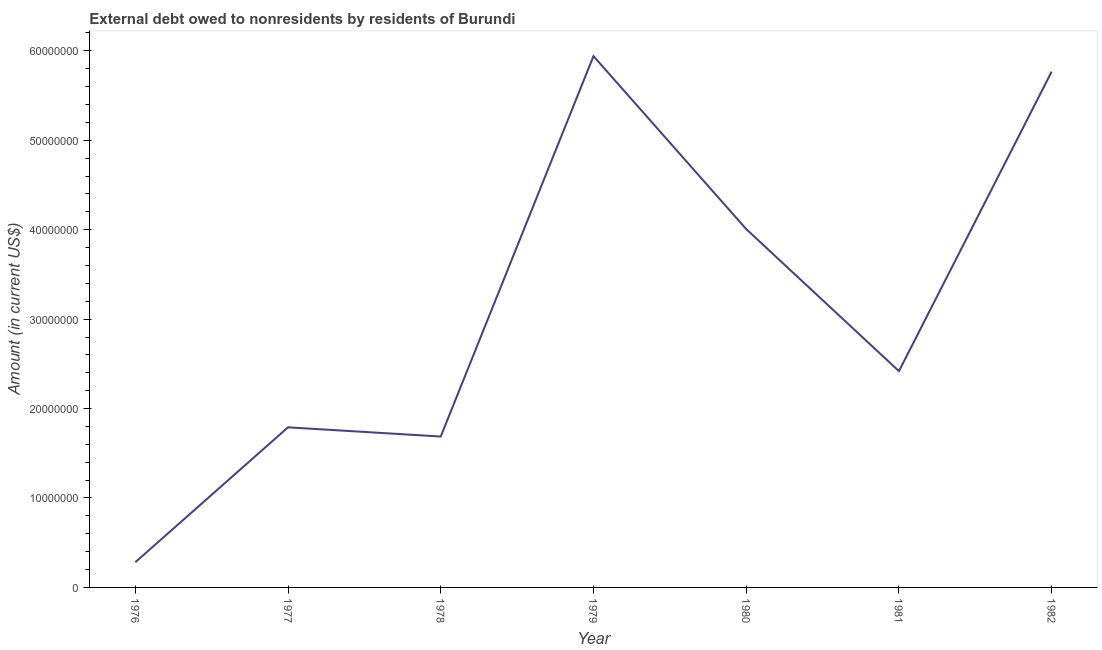What is the debt in 1979?
Provide a succinct answer. 5.94e+07. Across all years, what is the maximum debt?
Make the answer very short. 5.94e+07. Across all years, what is the minimum debt?
Offer a terse response. 2.81e+06. In which year was the debt maximum?
Provide a succinct answer. 1979. In which year was the debt minimum?
Provide a short and direct response. 1976. What is the sum of the debt?
Provide a short and direct response. 2.19e+08. What is the difference between the debt in 1976 and 1981?
Provide a succinct answer. -2.14e+07. What is the average debt per year?
Keep it short and to the point. 3.13e+07. What is the median debt?
Provide a succinct answer. 2.42e+07. What is the ratio of the debt in 1976 to that in 1982?
Offer a terse response. 0.05. Is the difference between the debt in 1976 and 1981 greater than the difference between any two years?
Provide a succinct answer. No. What is the difference between the highest and the second highest debt?
Provide a succinct answer. 1.73e+06. What is the difference between the highest and the lowest debt?
Your answer should be very brief. 5.66e+07. In how many years, is the debt greater than the average debt taken over all years?
Make the answer very short. 3. How many lines are there?
Provide a succinct answer. 1. How many years are there in the graph?
Keep it short and to the point. 7. What is the title of the graph?
Your answer should be compact. External debt owed to nonresidents by residents of Burundi. What is the label or title of the X-axis?
Give a very brief answer. Year. What is the label or title of the Y-axis?
Offer a very short reply. Amount (in current US$). What is the Amount (in current US$) in 1976?
Give a very brief answer. 2.81e+06. What is the Amount (in current US$) of 1977?
Ensure brevity in your answer.  1.79e+07. What is the Amount (in current US$) in 1978?
Your answer should be very brief. 1.69e+07. What is the Amount (in current US$) in 1979?
Offer a very short reply. 5.94e+07. What is the Amount (in current US$) in 1980?
Keep it short and to the point. 4.01e+07. What is the Amount (in current US$) of 1981?
Keep it short and to the point. 2.42e+07. What is the Amount (in current US$) of 1982?
Offer a terse response. 5.77e+07. What is the difference between the Amount (in current US$) in 1976 and 1977?
Offer a terse response. -1.51e+07. What is the difference between the Amount (in current US$) in 1976 and 1978?
Provide a short and direct response. -1.41e+07. What is the difference between the Amount (in current US$) in 1976 and 1979?
Provide a short and direct response. -5.66e+07. What is the difference between the Amount (in current US$) in 1976 and 1980?
Your response must be concise. -3.73e+07. What is the difference between the Amount (in current US$) in 1976 and 1981?
Provide a succinct answer. -2.14e+07. What is the difference between the Amount (in current US$) in 1976 and 1982?
Offer a very short reply. -5.49e+07. What is the difference between the Amount (in current US$) in 1977 and 1978?
Make the answer very short. 1.03e+06. What is the difference between the Amount (in current US$) in 1977 and 1979?
Your answer should be very brief. -4.15e+07. What is the difference between the Amount (in current US$) in 1977 and 1980?
Your answer should be compact. -2.22e+07. What is the difference between the Amount (in current US$) in 1977 and 1981?
Offer a very short reply. -6.28e+06. What is the difference between the Amount (in current US$) in 1977 and 1982?
Ensure brevity in your answer.  -3.98e+07. What is the difference between the Amount (in current US$) in 1978 and 1979?
Offer a very short reply. -4.25e+07. What is the difference between the Amount (in current US$) in 1978 and 1980?
Your response must be concise. -2.32e+07. What is the difference between the Amount (in current US$) in 1978 and 1981?
Provide a succinct answer. -7.31e+06. What is the difference between the Amount (in current US$) in 1978 and 1982?
Your answer should be very brief. -4.08e+07. What is the difference between the Amount (in current US$) in 1979 and 1980?
Keep it short and to the point. 1.93e+07. What is the difference between the Amount (in current US$) in 1979 and 1981?
Keep it short and to the point. 3.52e+07. What is the difference between the Amount (in current US$) in 1979 and 1982?
Your answer should be very brief. 1.73e+06. What is the difference between the Amount (in current US$) in 1980 and 1981?
Provide a succinct answer. 1.59e+07. What is the difference between the Amount (in current US$) in 1980 and 1982?
Your answer should be compact. -1.76e+07. What is the difference between the Amount (in current US$) in 1981 and 1982?
Give a very brief answer. -3.35e+07. What is the ratio of the Amount (in current US$) in 1976 to that in 1977?
Ensure brevity in your answer.  0.16. What is the ratio of the Amount (in current US$) in 1976 to that in 1978?
Keep it short and to the point. 0.17. What is the ratio of the Amount (in current US$) in 1976 to that in 1979?
Provide a short and direct response. 0.05. What is the ratio of the Amount (in current US$) in 1976 to that in 1980?
Your answer should be compact. 0.07. What is the ratio of the Amount (in current US$) in 1976 to that in 1981?
Offer a terse response. 0.12. What is the ratio of the Amount (in current US$) in 1976 to that in 1982?
Keep it short and to the point. 0.05. What is the ratio of the Amount (in current US$) in 1977 to that in 1978?
Your response must be concise. 1.06. What is the ratio of the Amount (in current US$) in 1977 to that in 1979?
Make the answer very short. 0.3. What is the ratio of the Amount (in current US$) in 1977 to that in 1980?
Provide a short and direct response. 0.45. What is the ratio of the Amount (in current US$) in 1977 to that in 1981?
Your answer should be compact. 0.74. What is the ratio of the Amount (in current US$) in 1977 to that in 1982?
Offer a terse response. 0.31. What is the ratio of the Amount (in current US$) in 1978 to that in 1979?
Keep it short and to the point. 0.28. What is the ratio of the Amount (in current US$) in 1978 to that in 1980?
Keep it short and to the point. 0.42. What is the ratio of the Amount (in current US$) in 1978 to that in 1981?
Your answer should be compact. 0.7. What is the ratio of the Amount (in current US$) in 1978 to that in 1982?
Keep it short and to the point. 0.29. What is the ratio of the Amount (in current US$) in 1979 to that in 1980?
Make the answer very short. 1.48. What is the ratio of the Amount (in current US$) in 1979 to that in 1981?
Keep it short and to the point. 2.46. What is the ratio of the Amount (in current US$) in 1979 to that in 1982?
Offer a terse response. 1.03. What is the ratio of the Amount (in current US$) in 1980 to that in 1981?
Offer a terse response. 1.66. What is the ratio of the Amount (in current US$) in 1980 to that in 1982?
Provide a short and direct response. 0.69. What is the ratio of the Amount (in current US$) in 1981 to that in 1982?
Keep it short and to the point. 0.42. 